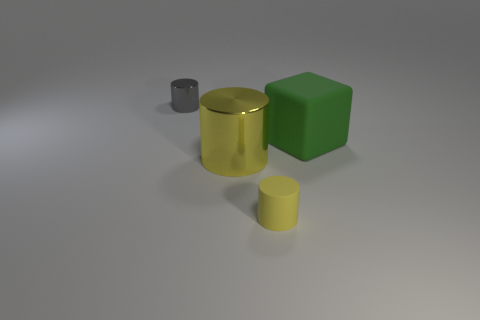How many blue matte blocks are there?
Ensure brevity in your answer.  0. What number of cylinders are either big green things or tiny cyan matte things?
Your answer should be very brief. 0. There is a large object that is to the right of the yellow object that is in front of the large yellow metallic cylinder; what number of yellow objects are to the left of it?
Keep it short and to the point. 2. There is a metallic object that is the same size as the yellow matte cylinder; what color is it?
Your answer should be compact. Gray. How many other things are there of the same color as the small rubber cylinder?
Your response must be concise. 1. Is the number of tiny gray metallic cylinders that are right of the tiny matte thing greater than the number of yellow metal cylinders?
Offer a terse response. No. Do the green object and the small gray cylinder have the same material?
Offer a very short reply. No. What number of objects are small things that are on the left side of the large metal cylinder or big brown balls?
Provide a succinct answer. 1. What number of other things are there of the same size as the green rubber thing?
Offer a terse response. 1. Are there an equal number of cylinders that are on the left side of the yellow metal object and tiny gray cylinders in front of the gray metal object?
Your answer should be compact. No. 